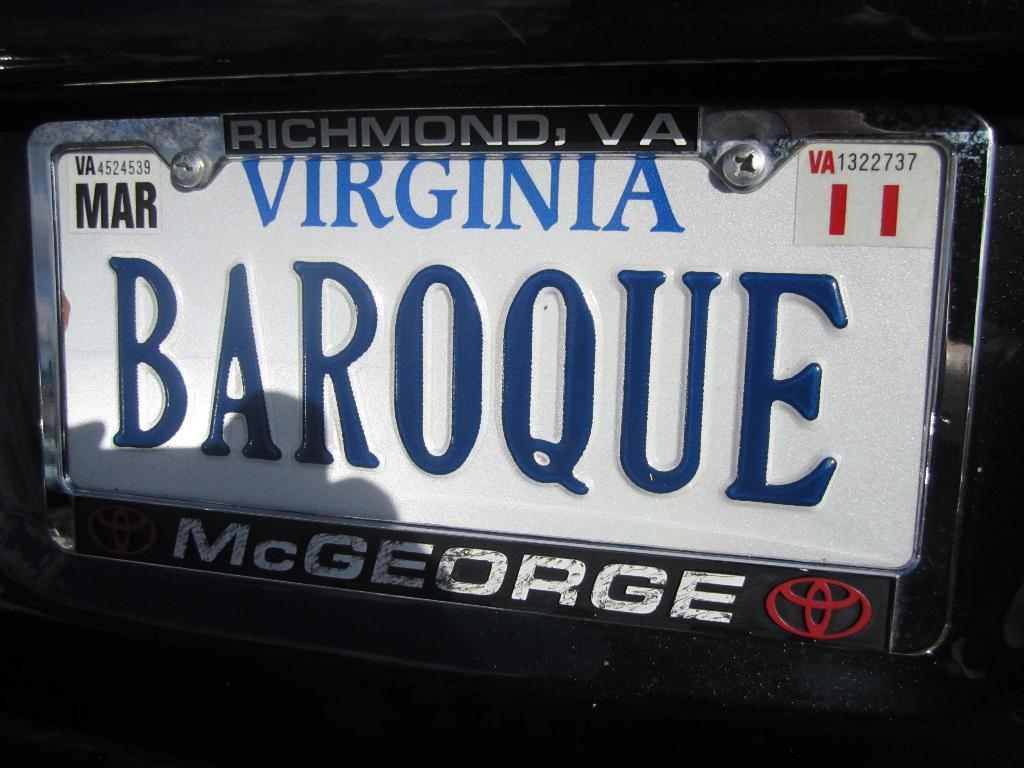<image>
Present a compact description of the photo's key features. a virginia license plate with a name on it 